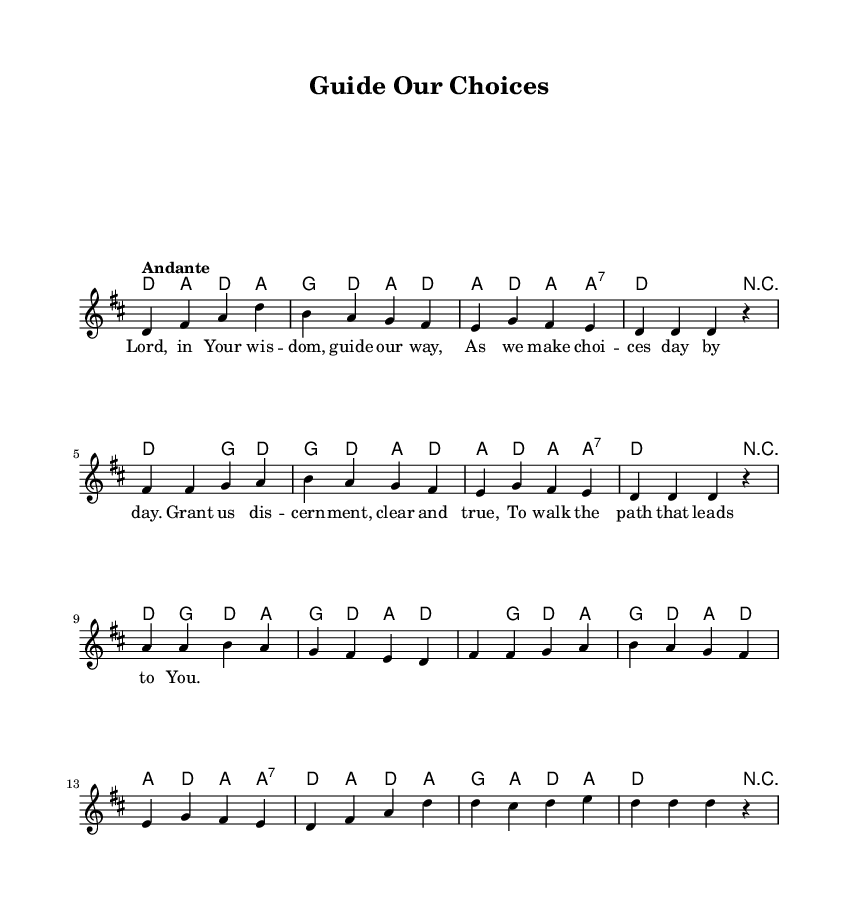What is the key signature of this music? The key signature shown at the beginning indicates two sharps, which corresponds to D major.
Answer: D major What is the time signature of this piece? The time signature appears as 4/4, which indicates four beats per measure with a quarter note receiving one beat.
Answer: 4/4 What is the tempo marking for this hymn? The tempo marking states "Andante," which suggests a moderate walking pace in terms of speed.
Answer: Andante How many measures are there in the melody? By counting the distinct groupings in the melody section, we find there are 16 measures in total.
Answer: 16 What is the first lyric line in the hymn? Looking at the lyrics section, the text aligned with the first measure of melody reads "Lord, in Your wis -- dom, guide our way".
Answer: Lord, in Your wisdom, guide our way Which note appears most frequently throughout the melody? By analyzing the melody notes, the note D appears repeatedly across numerous measures.
Answer: D What is the chord associated with the first measure? The chord in the first measure consists of the notes D, A, and D again, indicating a D major chord.
Answer: D major 